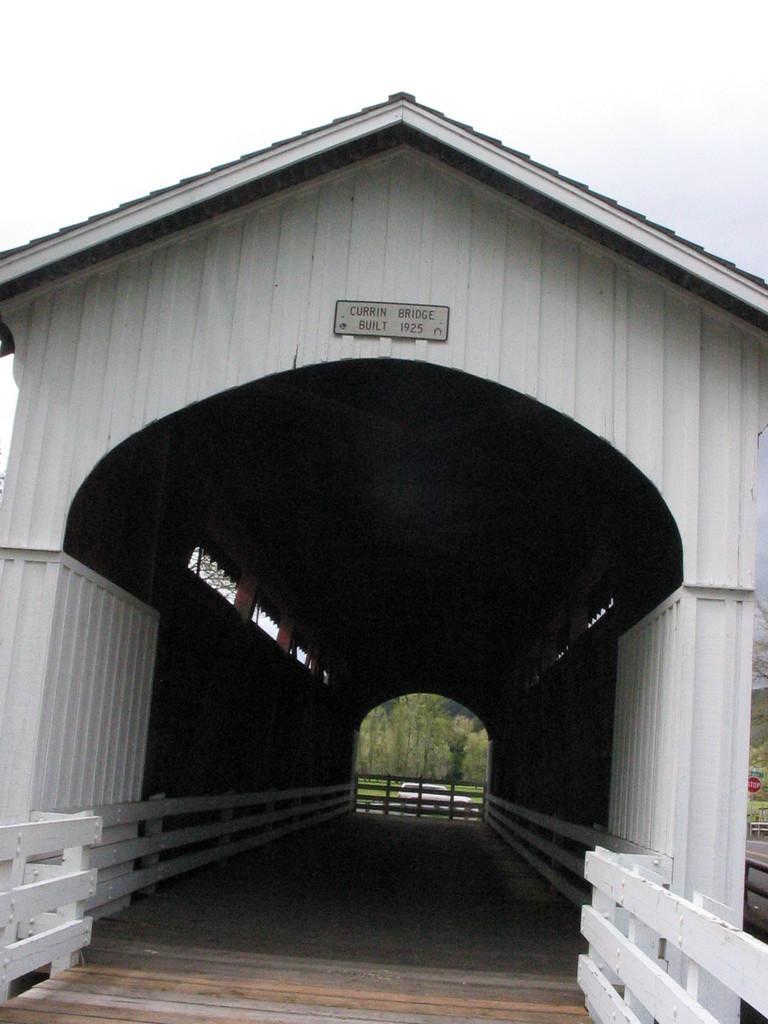Describe this image in one or two sentences. In the center of the image, we can see a bridge and there is a board on it. In the background, there are trees and we can see a vehicle. 